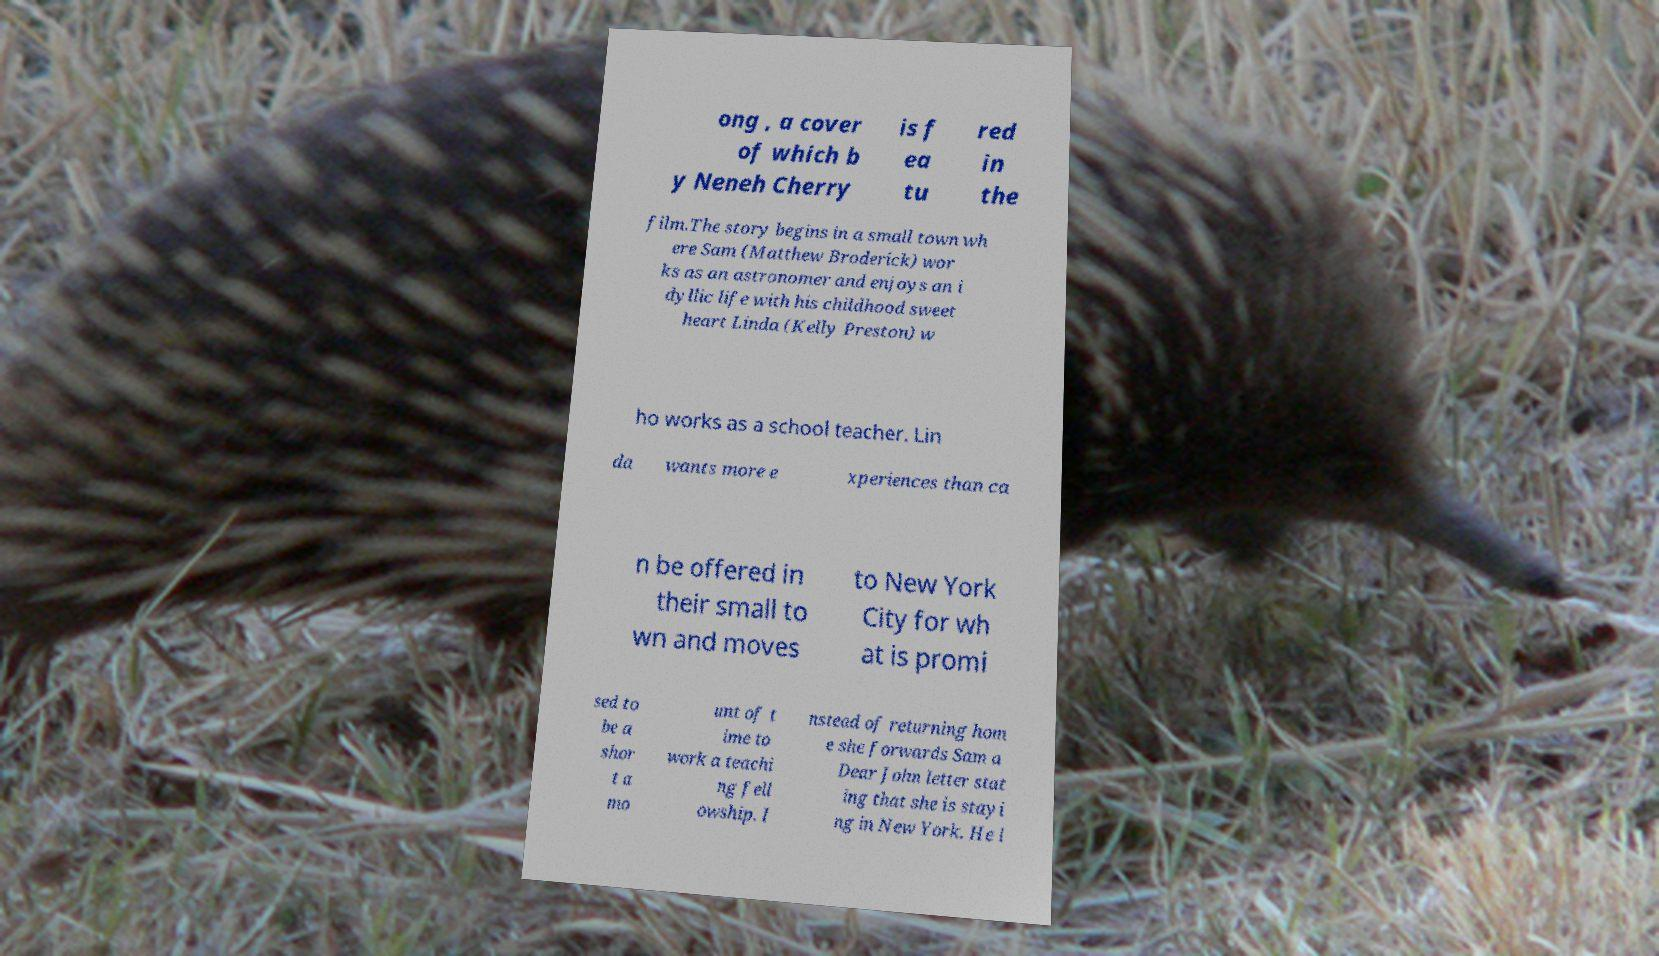I need the written content from this picture converted into text. Can you do that? ong , a cover of which b y Neneh Cherry is f ea tu red in the film.The story begins in a small town wh ere Sam (Matthew Broderick) wor ks as an astronomer and enjoys an i dyllic life with his childhood sweet heart Linda (Kelly Preston) w ho works as a school teacher. Lin da wants more e xperiences than ca n be offered in their small to wn and moves to New York City for wh at is promi sed to be a shor t a mo unt of t ime to work a teachi ng fell owship. I nstead of returning hom e she forwards Sam a Dear John letter stat ing that she is stayi ng in New York. He l 